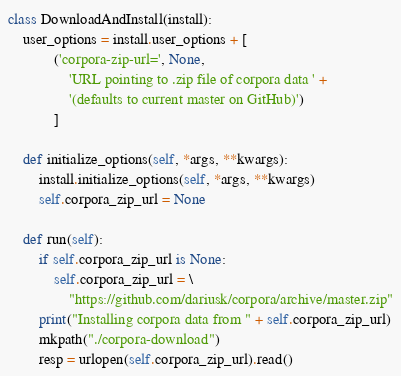<code> <loc_0><loc_0><loc_500><loc_500><_Python_>
class DownloadAndInstall(install):
    user_options = install.user_options + [
            ('corpora-zip-url=', None,
                'URL pointing to .zip file of corpora data ' +
                '(defaults to current master on GitHub)')
            ]

    def initialize_options(self, *args, **kwargs):
        install.initialize_options(self, *args, **kwargs)
        self.corpora_zip_url = None

    def run(self):
        if self.corpora_zip_url is None:
            self.corpora_zip_url = \
                "https://github.com/dariusk/corpora/archive/master.zip"
        print("Installing corpora data from " + self.corpora_zip_url)
        mkpath("./corpora-download")
        resp = urlopen(self.corpora_zip_url).read()</code> 